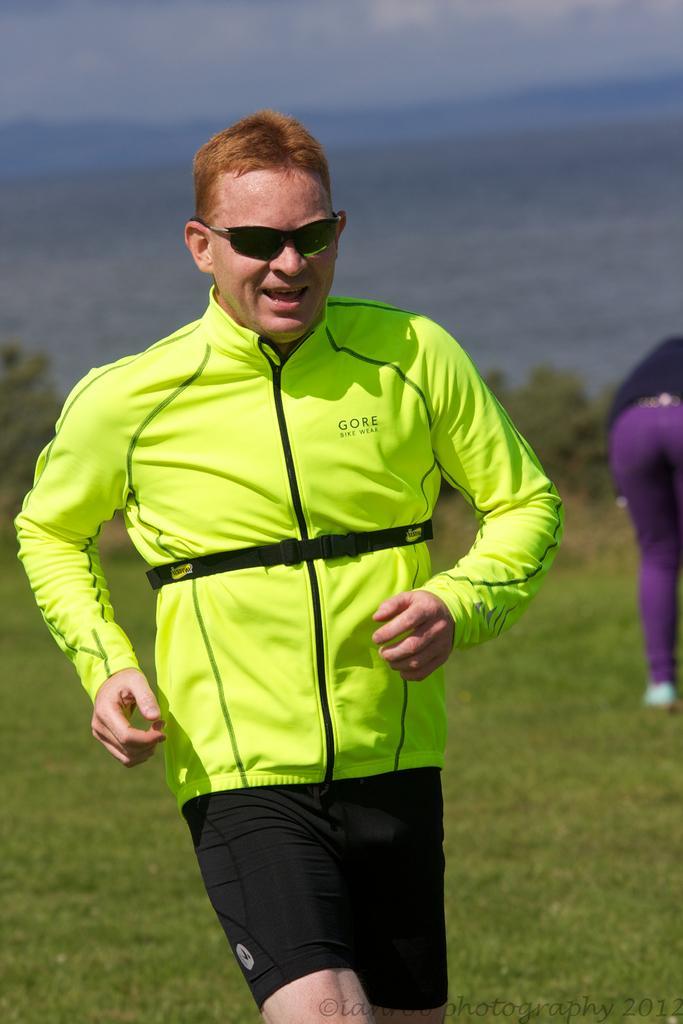Can you describe this image briefly? In this image I can see a person wearing spectacles and green color shirt visible in the middle and I can see person's legs visible on the right side , in the middle I can see grass ,at the top I can see the sky. 